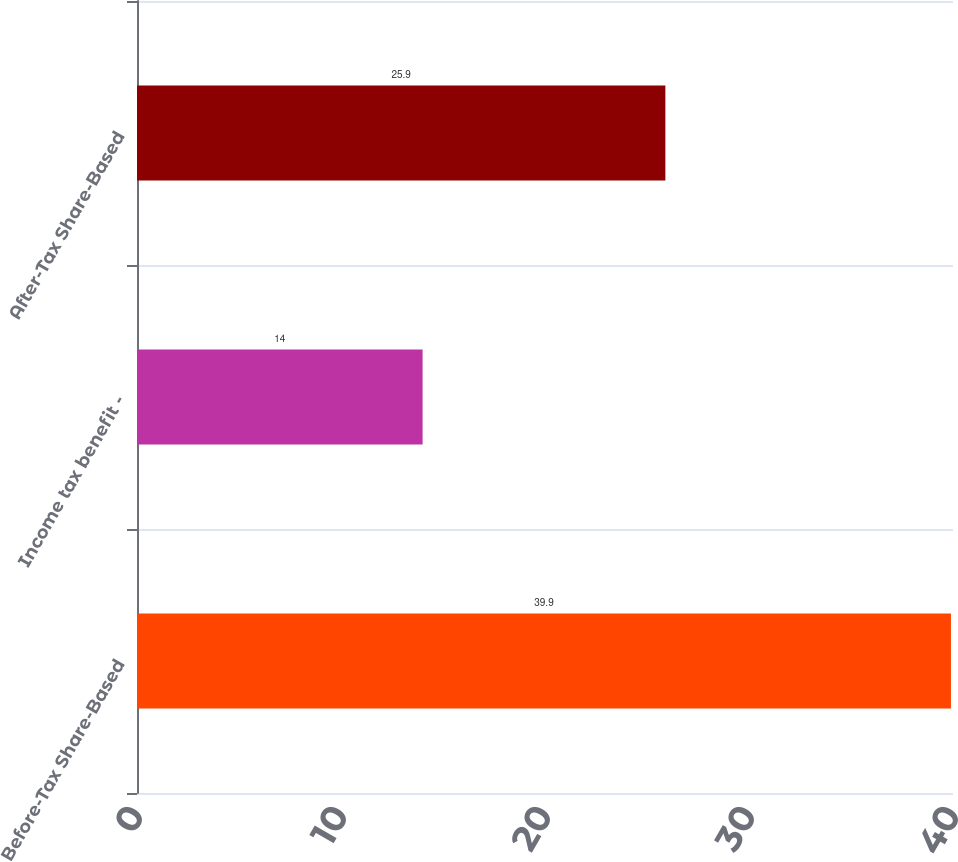Convert chart to OTSL. <chart><loc_0><loc_0><loc_500><loc_500><bar_chart><fcel>Before-Tax Share-Based<fcel>Income tax benefit -<fcel>After-Tax Share-Based<nl><fcel>39.9<fcel>14<fcel>25.9<nl></chart> 